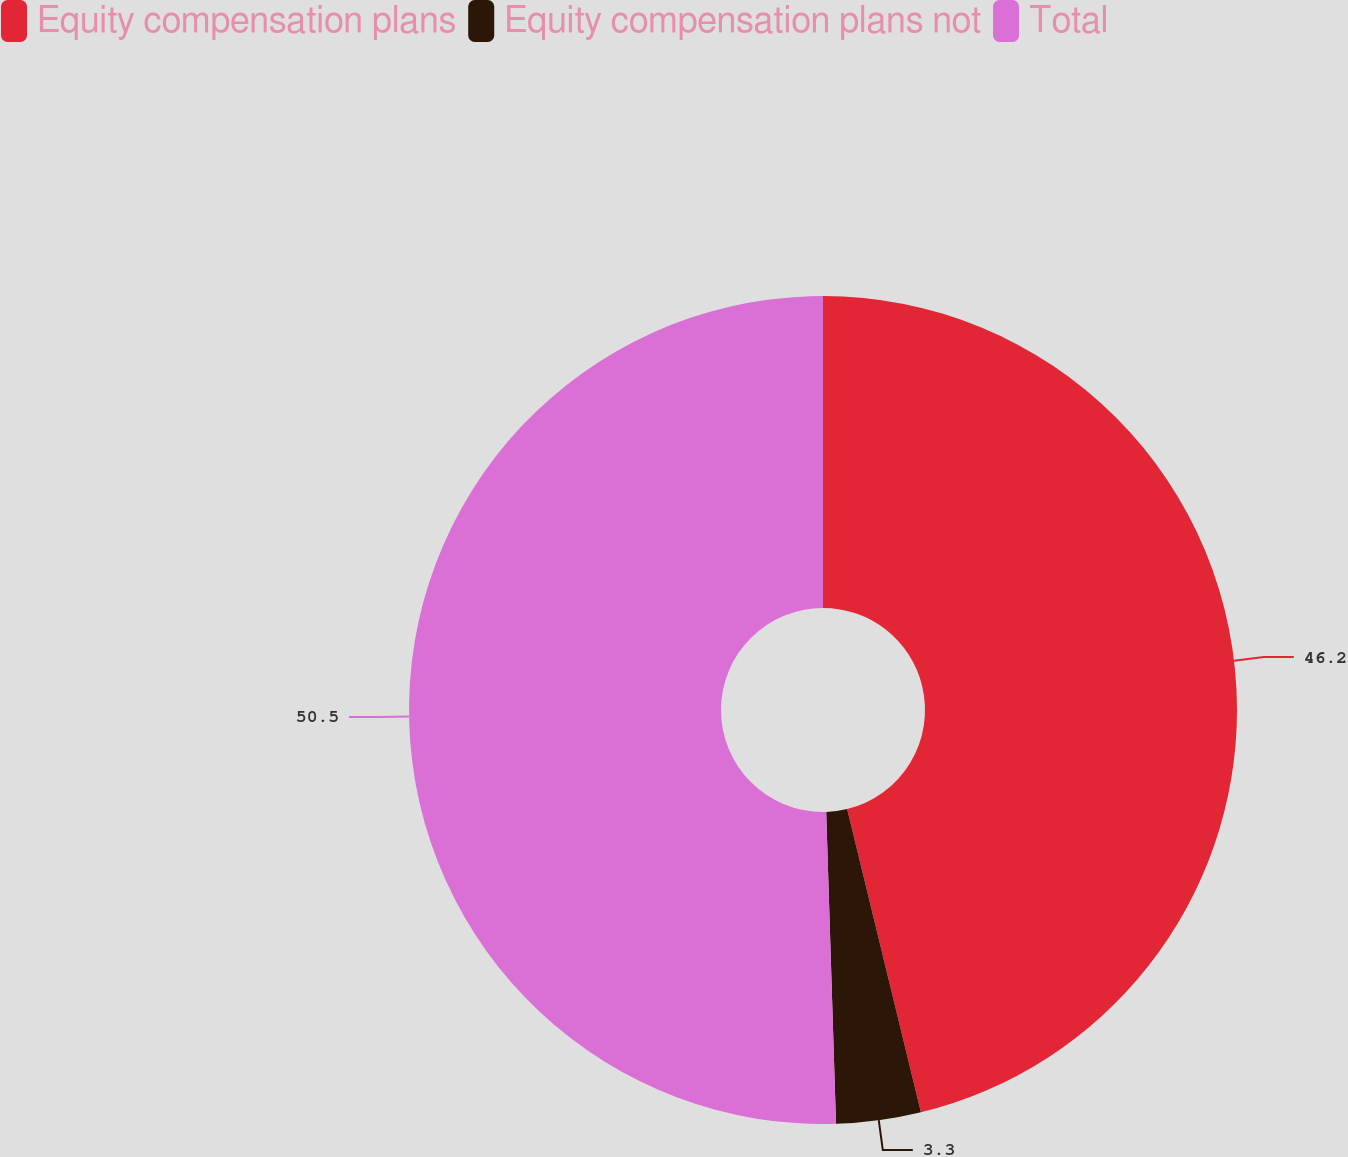<chart> <loc_0><loc_0><loc_500><loc_500><pie_chart><fcel>Equity compensation plans<fcel>Equity compensation plans not<fcel>Total<nl><fcel>46.2%<fcel>3.3%<fcel>50.5%<nl></chart> 